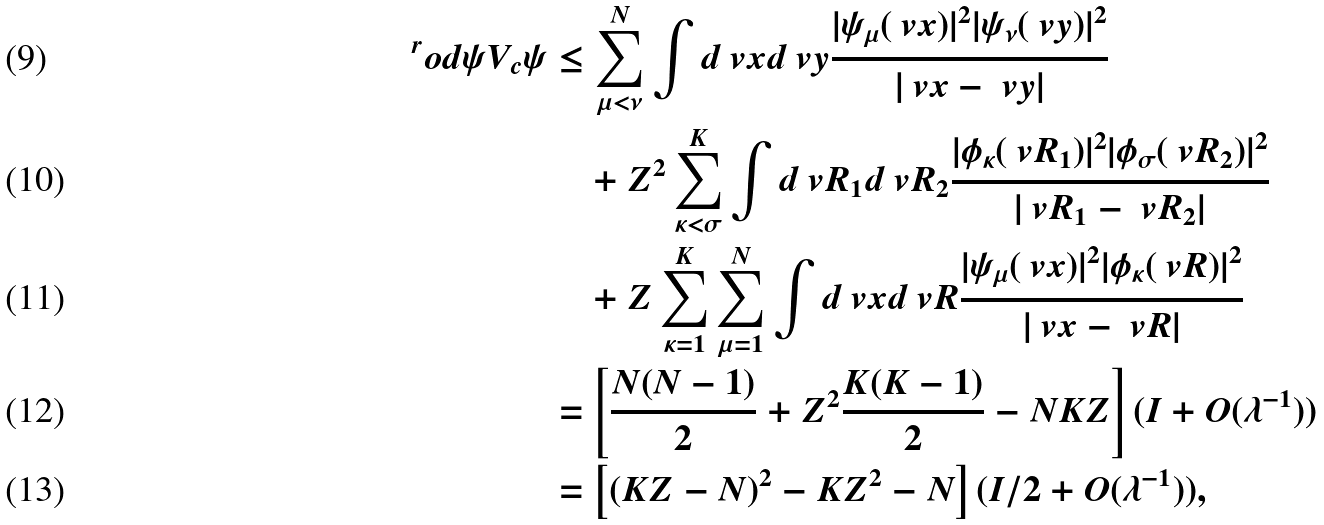<formula> <loc_0><loc_0><loc_500><loc_500>^ { r } o d { \psi } { V _ { c } \psi } & \leq \sum _ { \mu < \nu } ^ { N } \int d \ v x d \ v y \frac { | \psi _ { \mu } ( \ v x ) | ^ { 2 } | \psi _ { \nu } ( \ v y ) | ^ { 2 } } { | \ v x - \ v y | } \\ & \quad + Z ^ { 2 } \sum _ { \kappa < \sigma } ^ { K } \int d \ v R _ { 1 } d \ v R _ { 2 } \frac { | \phi _ { \kappa } ( \ v R _ { 1 } ) | ^ { 2 } | \phi _ { \sigma } ( \ v R _ { 2 } ) | ^ { 2 } } { | \ v R _ { 1 } - \ v R _ { 2 } | } \\ & \quad + Z \sum _ { \kappa = 1 } ^ { K } \sum _ { \mu = 1 } ^ { N } \int d \ v x d \ v R \frac { | \psi _ { \mu } ( \ v x ) | ^ { 2 } | \phi _ { \kappa } ( \ v R ) | ^ { 2 } } { | \ v x - \ v R | } \\ & = \left [ \frac { N ( N - 1 ) } { 2 } + Z ^ { 2 } \frac { K ( K - 1 ) } { 2 } - N K Z \right ] ( I + O ( \lambda ^ { - 1 } ) ) \\ & = \left [ ( K Z - N ) ^ { 2 } - K Z ^ { 2 } - N \right ] ( I / 2 + O ( \lambda ^ { - 1 } ) ) ,</formula> 